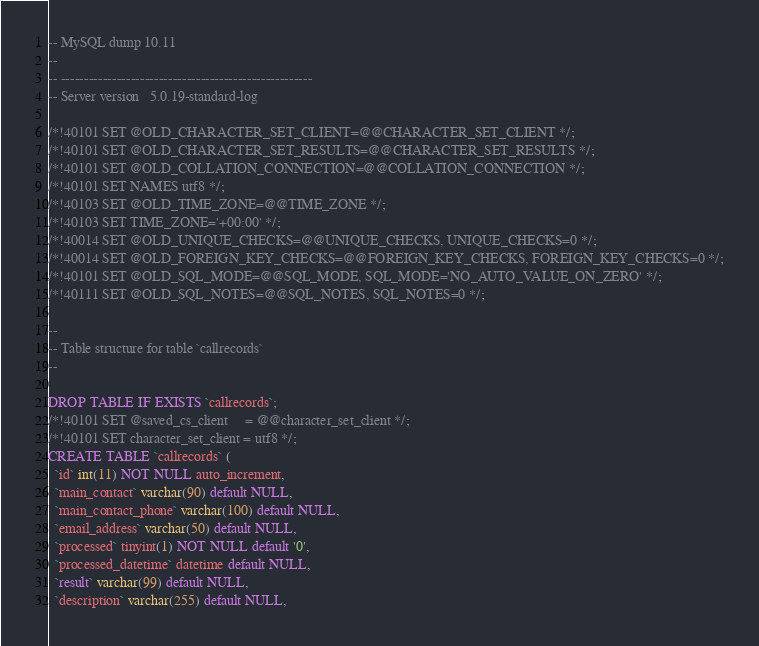Convert code to text. <code><loc_0><loc_0><loc_500><loc_500><_SQL_>-- MySQL dump 10.11
--
-- ------------------------------------------------------
-- Server version	5.0.19-standard-log

/*!40101 SET @OLD_CHARACTER_SET_CLIENT=@@CHARACTER_SET_CLIENT */;
/*!40101 SET @OLD_CHARACTER_SET_RESULTS=@@CHARACTER_SET_RESULTS */;
/*!40101 SET @OLD_COLLATION_CONNECTION=@@COLLATION_CONNECTION */;
/*!40101 SET NAMES utf8 */;
/*!40103 SET @OLD_TIME_ZONE=@@TIME_ZONE */;
/*!40103 SET TIME_ZONE='+00:00' */;
/*!40014 SET @OLD_UNIQUE_CHECKS=@@UNIQUE_CHECKS, UNIQUE_CHECKS=0 */;
/*!40014 SET @OLD_FOREIGN_KEY_CHECKS=@@FOREIGN_KEY_CHECKS, FOREIGN_KEY_CHECKS=0 */;
/*!40101 SET @OLD_SQL_MODE=@@SQL_MODE, SQL_MODE='NO_AUTO_VALUE_ON_ZERO' */;
/*!40111 SET @OLD_SQL_NOTES=@@SQL_NOTES, SQL_NOTES=0 */;

--
-- Table structure for table `callrecords`
--

DROP TABLE IF EXISTS `callrecords`;
/*!40101 SET @saved_cs_client     = @@character_set_client */;
/*!40101 SET character_set_client = utf8 */;
CREATE TABLE `callrecords` (
  `id` int(11) NOT NULL auto_increment,
  `main_contact` varchar(90) default NULL,
  `main_contact_phone` varchar(100) default NULL,
  `email_address` varchar(50) default NULL,
  `processed` tinyint(1) NOT NULL default '0',
  `processed_datetime` datetime default NULL,
  `result` varchar(99) default NULL,
  `description` varchar(255) default NULL,</code> 